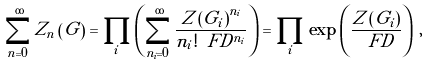Convert formula to latex. <formula><loc_0><loc_0><loc_500><loc_500>\sum _ { n = 0 } ^ { \infty } Z _ { n } \left ( G \right ) = \prod _ { i } \left ( \sum _ { n _ { i } = 0 } ^ { \infty } \frac { Z \left ( G _ { i } \right ) ^ { n _ { i } } } { n _ { i } ! \ F D ^ { n _ { i } } } \right ) = \prod _ { i } \exp \left ( \frac { Z \left ( G _ { i } \right ) } { \ F D } \right ) \, ,</formula> 